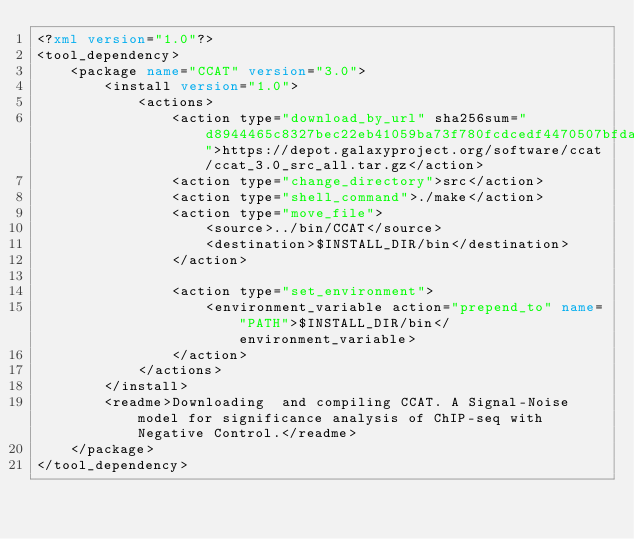Convert code to text. <code><loc_0><loc_0><loc_500><loc_500><_XML_><?xml version="1.0"?>
<tool_dependency>
    <package name="CCAT" version="3.0">
        <install version="1.0">
            <actions>
                <action type="download_by_url" sha256sum="d8944465c8327bec22eb41059ba73f780fcdcedf4470507bfdae5a54c59a9b07">https://depot.galaxyproject.org/software/ccat/ccat_3.0_src_all.tar.gz</action>
                <action type="change_directory">src</action>
                <action type="shell_command">./make</action>
                <action type="move_file">
                    <source>../bin/CCAT</source>
                    <destination>$INSTALL_DIR/bin</destination>
                </action>

                <action type="set_environment">
                    <environment_variable action="prepend_to" name="PATH">$INSTALL_DIR/bin</environment_variable>
                </action>
            </actions>
        </install>
        <readme>Downloading  and compiling CCAT. A Signal-Noise model for significance analysis of ChIP-seq with Negative Control.</readme>
    </package>
</tool_dependency>
</code> 